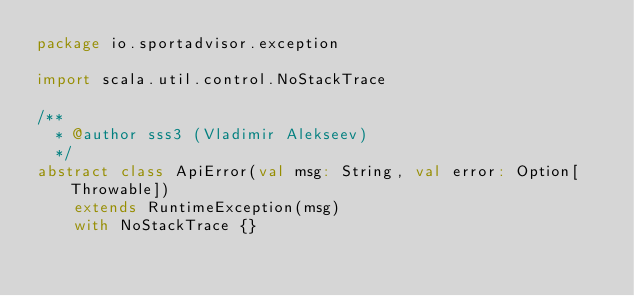<code> <loc_0><loc_0><loc_500><loc_500><_Scala_>package io.sportadvisor.exception

import scala.util.control.NoStackTrace

/**
  * @author sss3 (Vladimir Alekseev)
  */
abstract class ApiError(val msg: String, val error: Option[Throwable])
    extends RuntimeException(msg)
    with NoStackTrace {}
</code> 